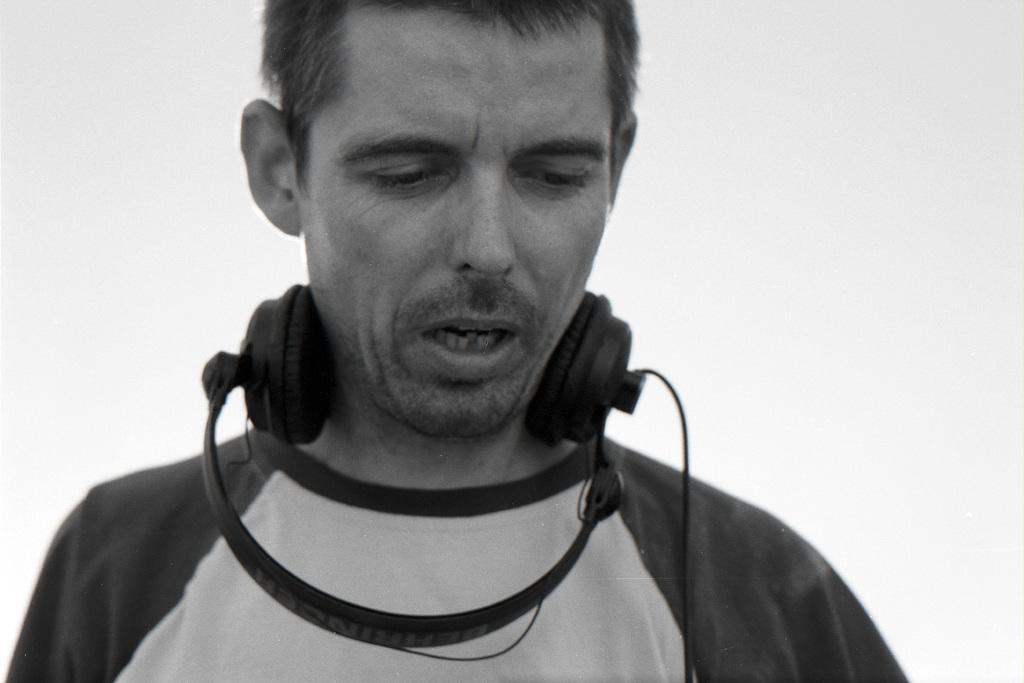How would you summarize this image in a sentence or two? It is a black and white image. In this image we can see a man with a headset and the background is in plain color. 